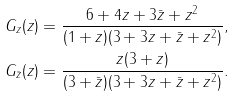<formula> <loc_0><loc_0><loc_500><loc_500>G _ { z } ( z ) & = \frac { 6 + 4 z + 3 \bar { z } + z ^ { 2 } } { ( 1 + z ) ( 3 + 3 z + \bar { z } + z ^ { 2 } ) } , \\ G _ { \bar { z } } ( z ) & = \frac { z ( 3 + z ) } { ( 3 + \bar { z } ) ( 3 + 3 z + \bar { z } + z ^ { 2 } ) } .</formula> 